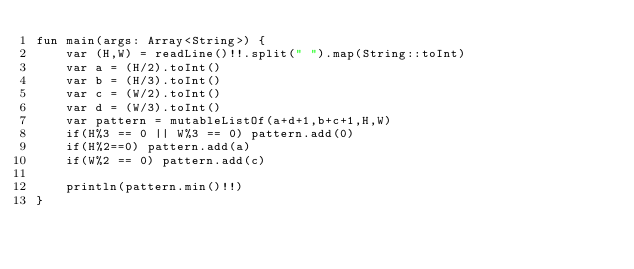Convert code to text. <code><loc_0><loc_0><loc_500><loc_500><_Kotlin_>fun main(args: Array<String>) {
    var (H,W) = readLine()!!.split(" ").map(String::toInt)
    var a = (H/2).toInt()
    var b = (H/3).toInt()
    var c = (W/2).toInt()
    var d = (W/3).toInt()
    var pattern = mutableListOf(a+d+1,b+c+1,H,W)
    if(H%3 == 0 || W%3 == 0) pattern.add(0)
    if(H%2==0) pattern.add(a)
    if(W%2 == 0) pattern.add(c)
    
    println(pattern.min()!!)
}
</code> 